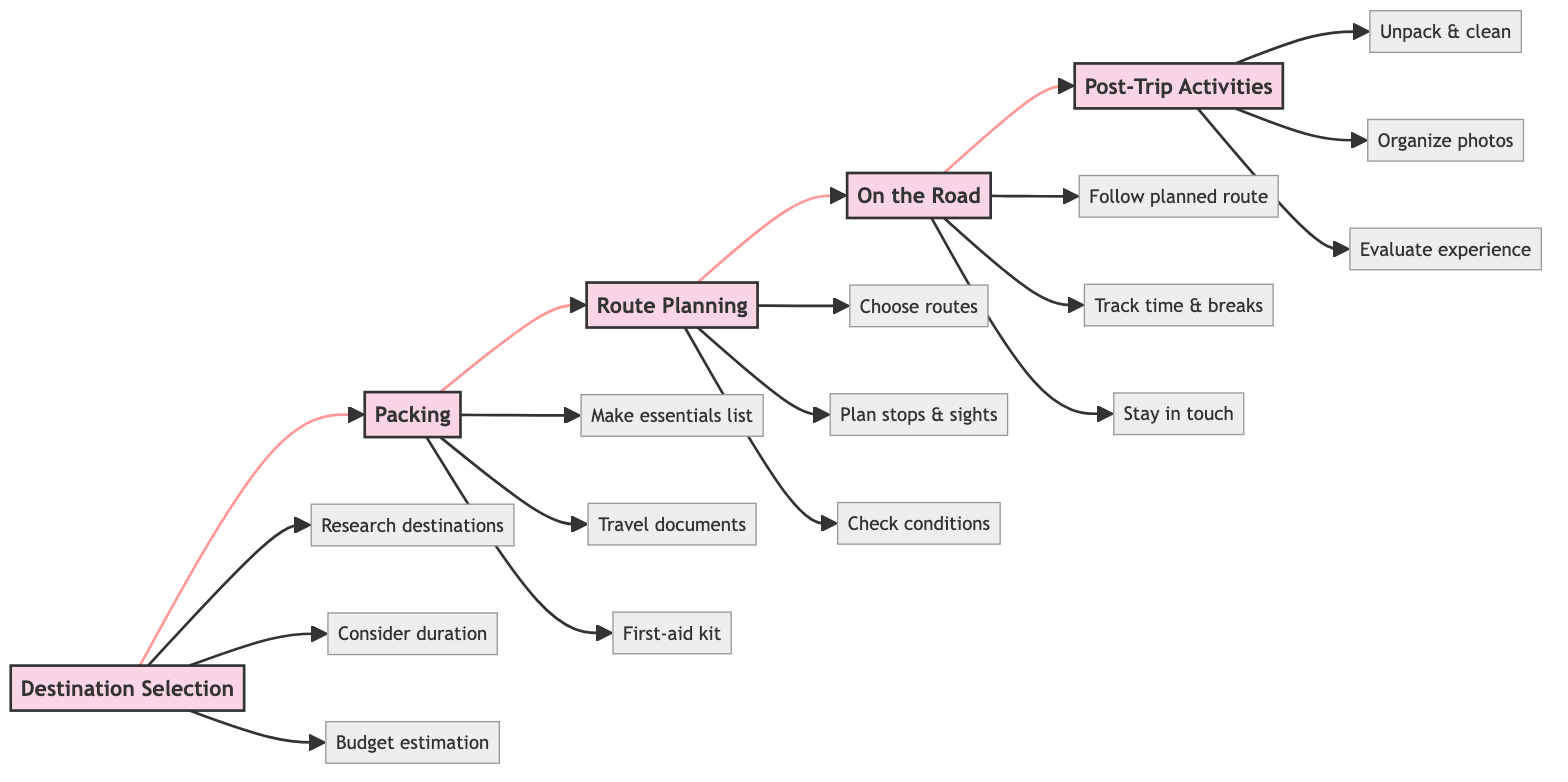What is the first step in the road trip preparation process? The diagram clearly identifies "Destination Selection" as the first step, indicated by the leftmost node in the horizontal flowchart.
Answer: Destination Selection How many main steps are there in the preparation process? The flowchart outlines five main steps connected in sequence: Destination Selection, Packing, Route Planning, On the Road, and Post-Trip Activities. Counting these gives a total of five steps.
Answer: 5 What is one essential item to pack? Reviewing the packing step, one essential item listed is "Clothes," which is part of the essentials list to prepare for the trip.
Answer: Clothes Which step involves evaluating the trip experience? The last step in the flowchart, labeled "Post-Trip Activities," includes evaluating the trip experience, as stated in the details for that node.
Answer: Post-Trip Activities What should you do during the "On the Road" step? The "On the Road" step includes several actions, one of which is "Follow the planned route," which is critical for ensuring the trip goes as intended.
Answer: Follow the planned route What is the last detailed activity mentioned in the flowchart? "Evaluate the trip experience" is the last detailed activity mentioned under the "Post-Trip Activities" step, showing what to do upon returning from the trip.
Answer: Evaluate the trip experience Which routing option appears in the "Route Planning" step? In the "Route Planning" step, one of the routing options mentioned is "I-40," which is noted as a primary route to consider during planning.
Answer: I-40 How many details are listed for the "Packing" step? The "Packing" step includes three details: making a list of essentials, bringing travel documents, and preparing a first-aid kit, resulting in a total of three items.
Answer: 3 What should you do every two hours while "On the Road"? The diagram advises that during the "On the Road" step, you should "Rest every 2 hours," providing a clear guideline for managing travel fatigue.
Answer: Rest every 2 hours 